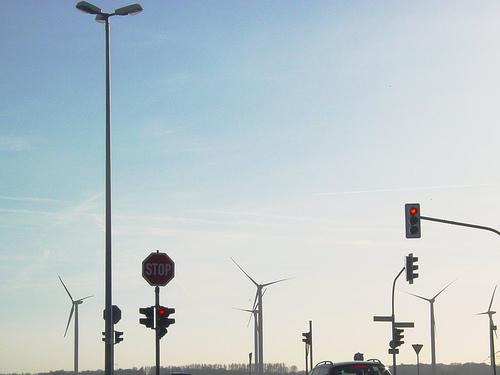The car is operating during which season? Please explain your reasoning. winter. The trees in the back look dead. 